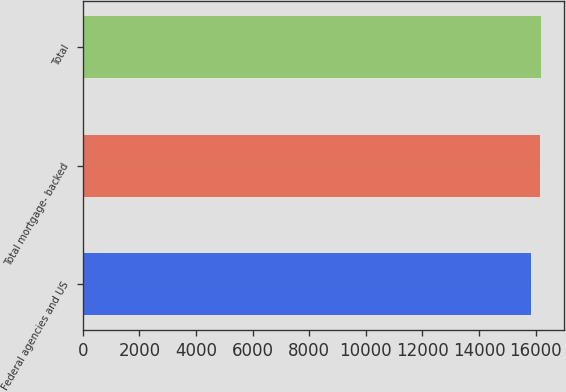Convert chart to OTSL. <chart><loc_0><loc_0><loc_500><loc_500><bar_chart><fcel>Federal agencies and US<fcel>Total mortgage- backed<fcel>Total<nl><fcel>15848<fcel>16158<fcel>16189.8<nl></chart> 